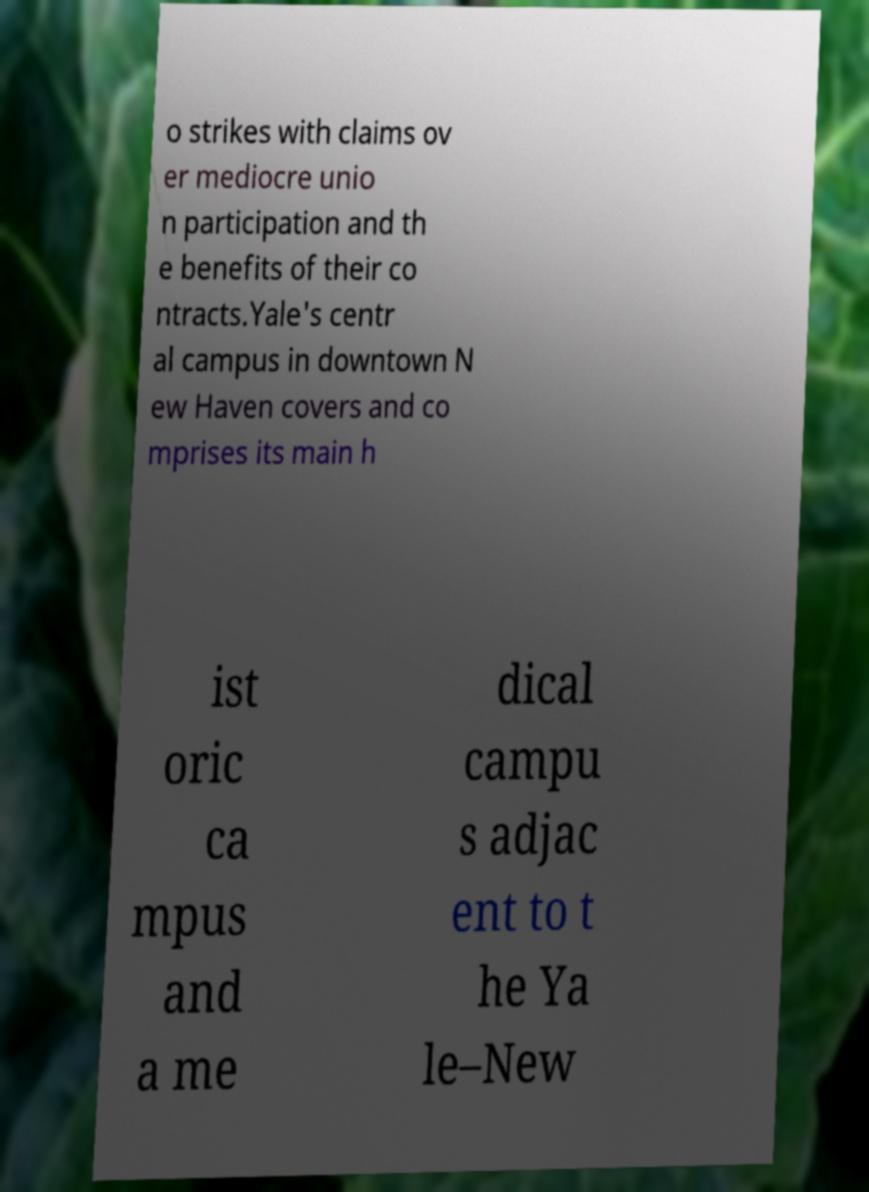I need the written content from this picture converted into text. Can you do that? o strikes with claims ov er mediocre unio n participation and th e benefits of their co ntracts.Yale's centr al campus in downtown N ew Haven covers and co mprises its main h ist oric ca mpus and a me dical campu s adjac ent to t he Ya le–New 